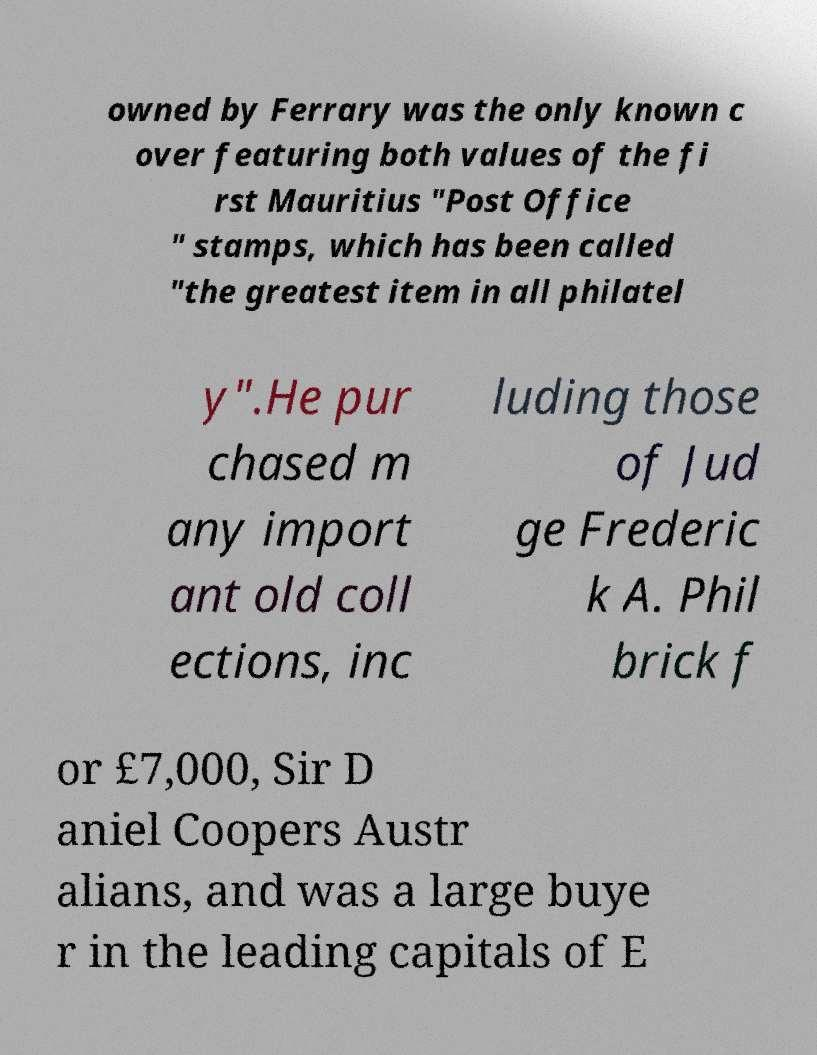Could you assist in decoding the text presented in this image and type it out clearly? owned by Ferrary was the only known c over featuring both values of the fi rst Mauritius "Post Office " stamps, which has been called "the greatest item in all philatel y".He pur chased m any import ant old coll ections, inc luding those of Jud ge Frederic k A. Phil brick f or £7,000, Sir D aniel Coopers Austr alians, and was a large buye r in the leading capitals of E 